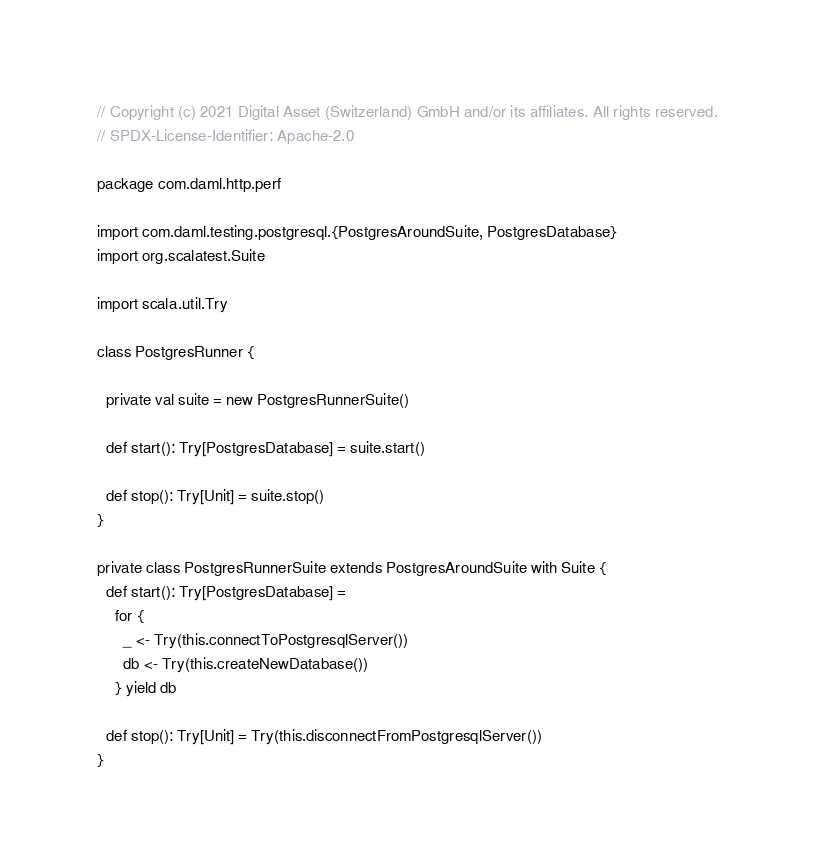<code> <loc_0><loc_0><loc_500><loc_500><_Scala_>// Copyright (c) 2021 Digital Asset (Switzerland) GmbH and/or its affiliates. All rights reserved.
// SPDX-License-Identifier: Apache-2.0

package com.daml.http.perf

import com.daml.testing.postgresql.{PostgresAroundSuite, PostgresDatabase}
import org.scalatest.Suite

import scala.util.Try

class PostgresRunner {

  private val suite = new PostgresRunnerSuite()

  def start(): Try[PostgresDatabase] = suite.start()

  def stop(): Try[Unit] = suite.stop()
}

private class PostgresRunnerSuite extends PostgresAroundSuite with Suite {
  def start(): Try[PostgresDatabase] =
    for {
      _ <- Try(this.connectToPostgresqlServer())
      db <- Try(this.createNewDatabase())
    } yield db

  def stop(): Try[Unit] = Try(this.disconnectFromPostgresqlServer())
}
</code> 